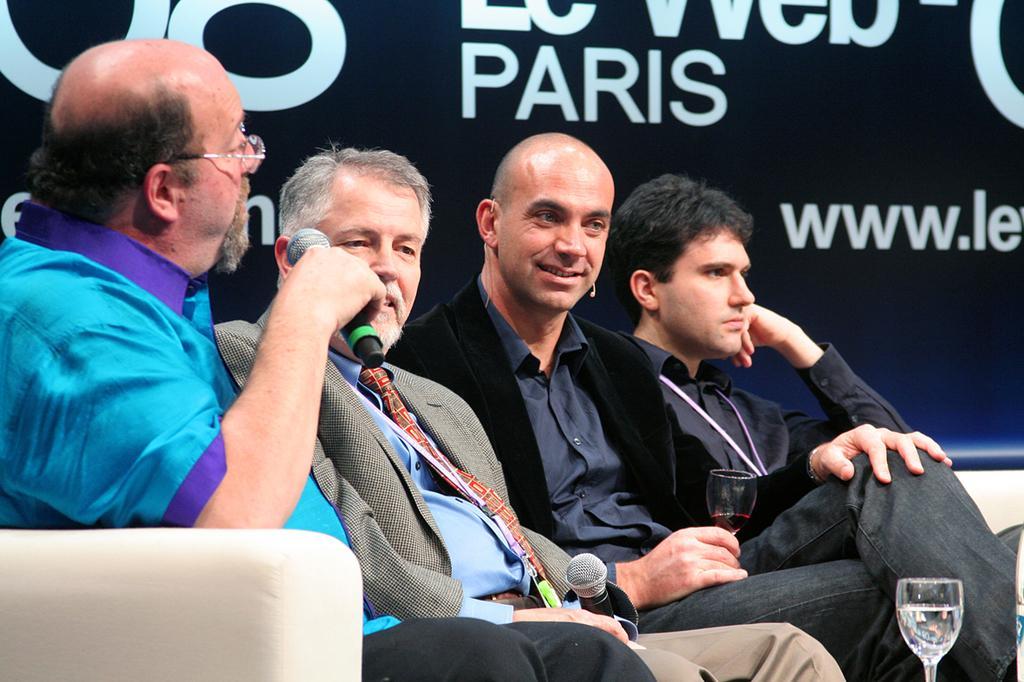Can you describe this image briefly? This image consists of four persons sitting in a sofa. On the left, the man wearing blue shirt is talking in a mic. In the background, there is a banner fixed on the wall. On the right, we can see a glass. 